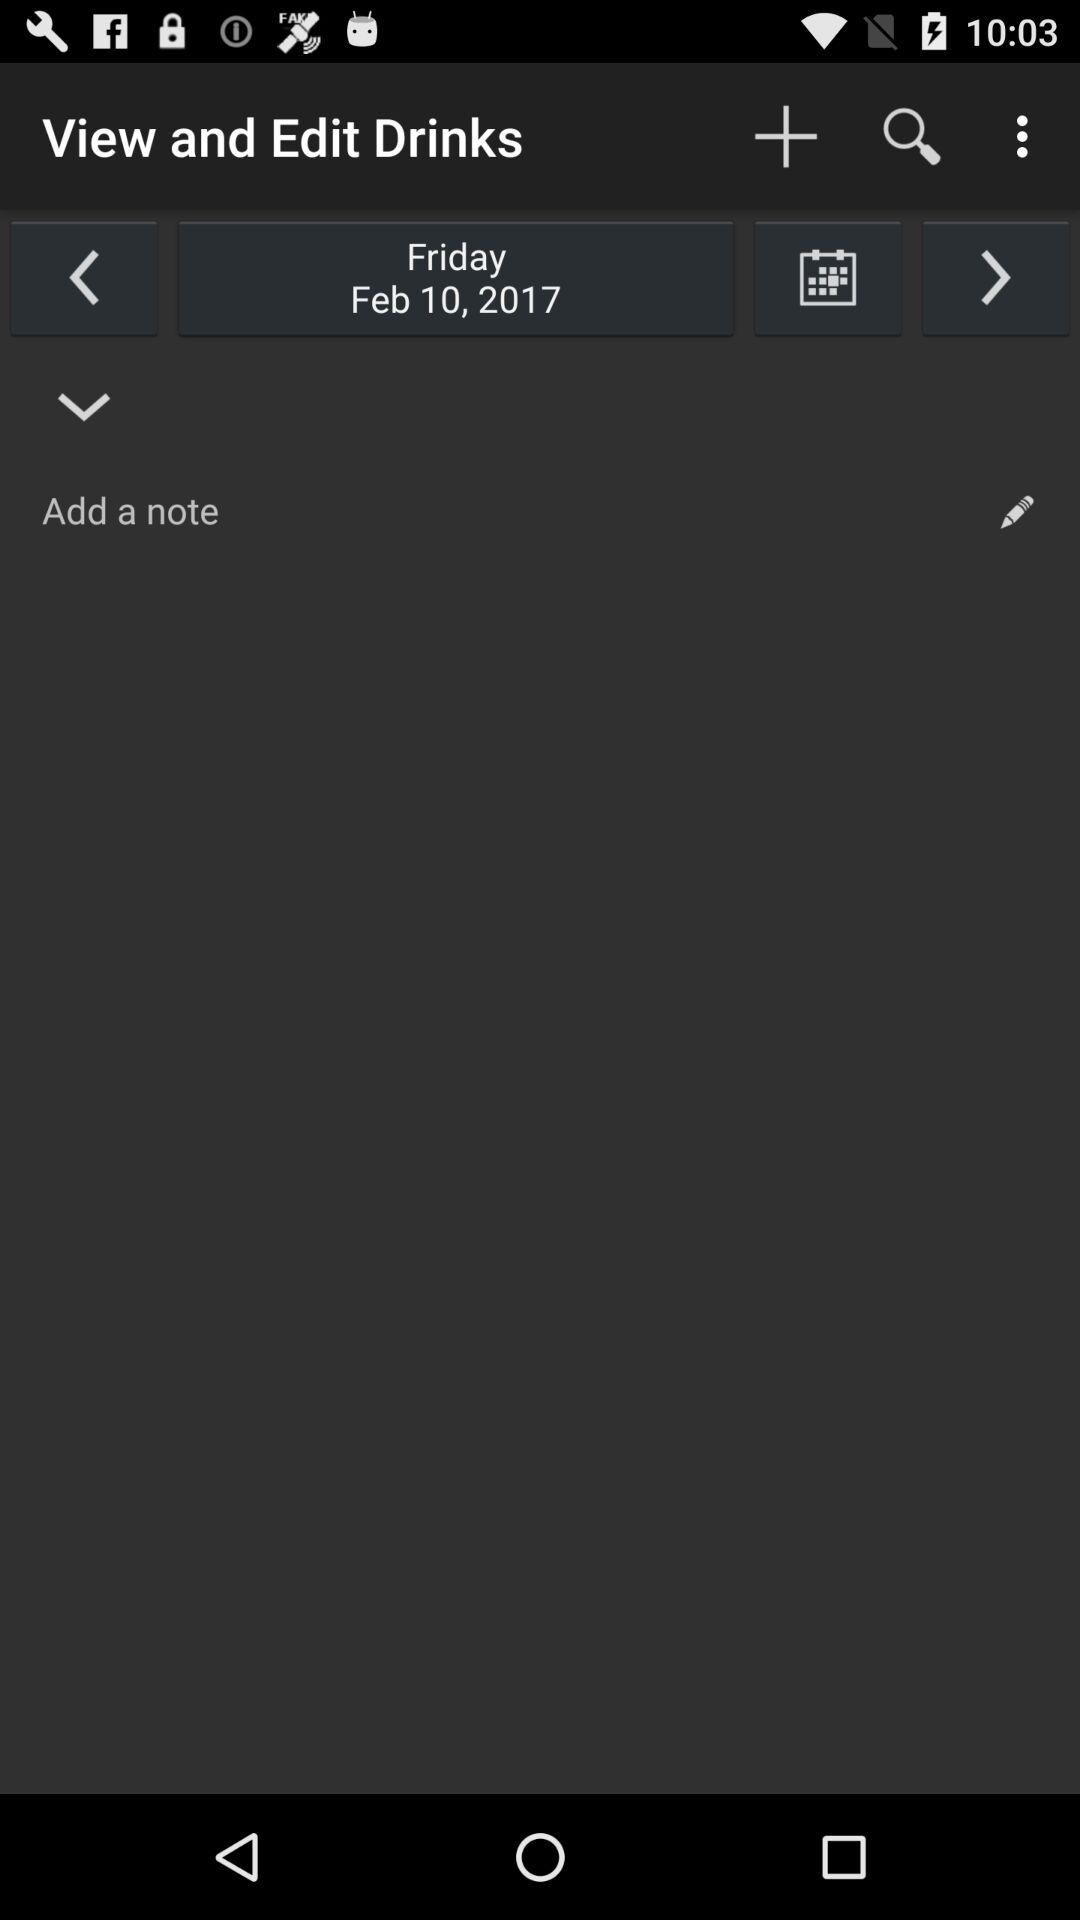What is the selected date? The selected date is Friday, February 10, 2017. 